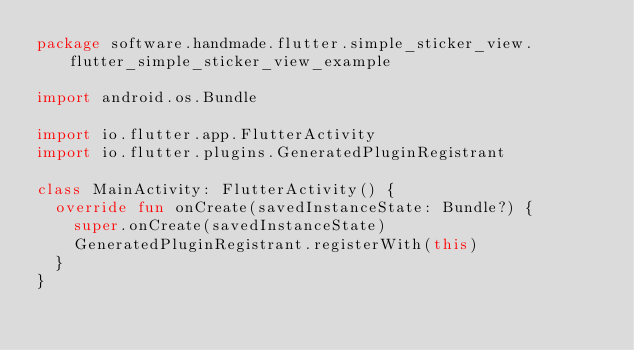<code> <loc_0><loc_0><loc_500><loc_500><_Kotlin_>package software.handmade.flutter.simple_sticker_view.flutter_simple_sticker_view_example

import android.os.Bundle

import io.flutter.app.FlutterActivity
import io.flutter.plugins.GeneratedPluginRegistrant

class MainActivity: FlutterActivity() {
  override fun onCreate(savedInstanceState: Bundle?) {
    super.onCreate(savedInstanceState)
    GeneratedPluginRegistrant.registerWith(this)
  }
}
</code> 